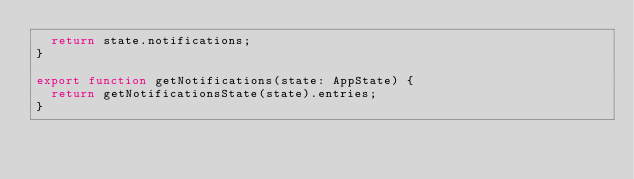<code> <loc_0><loc_0><loc_500><loc_500><_TypeScript_>  return state.notifications;
}

export function getNotifications(state: AppState) {
  return getNotificationsState(state).entries;
}
</code> 